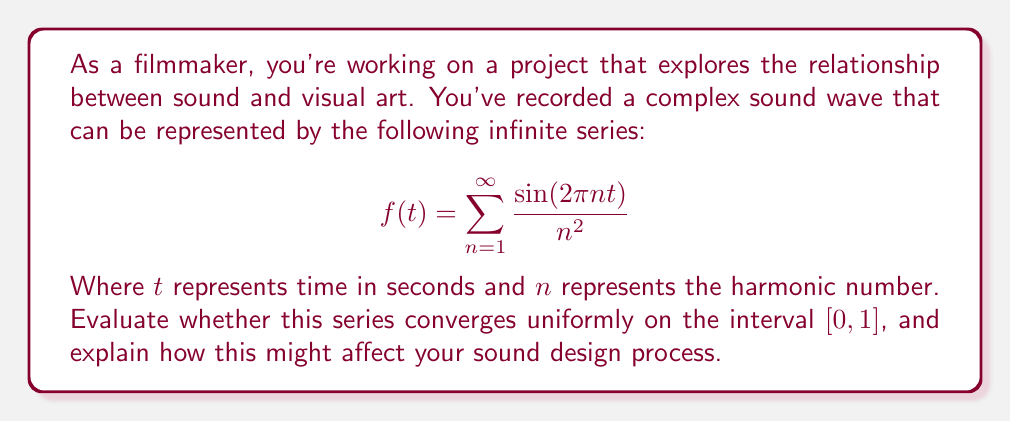Can you solve this math problem? To evaluate the uniform convergence of this series, we'll use the Weierstrass M-test. 

1) First, we need to find a sequence of constants $M_n$ such that:
   $$\left|\frac{\sin(2\pi n t)}{n^2}\right| \leq M_n$$
   for all $t \in [0,1]$ and all $n \geq 1$.

2) We know that $|\sin(x)| \leq 1$ for all $x$. Therefore:
   $$\left|\frac{\sin(2\pi n t)}{n^2}\right| \leq \frac{1}{n^2}$$

3) So we can choose $M_n = \frac{1}{n^2}$.

4) Now we need to check if $\sum_{n=1}^{\infty} M_n$ converges:
   $$\sum_{n=1}^{\infty} M_n = \sum_{n=1}^{\infty} \frac{1}{n^2}$$

5) This is the famous Basel problem series, which is known to converge to $\frac{\pi^2}{6}$.

6) Since $\sum_{n=1}^{\infty} M_n$ converges, by the Weierstrass M-test, the original series converges uniformly on $[0,1]$.

For a filmmaker, this uniform convergence has important implications:

1) The sound wave represented by this series is well-behaved and consistent across the entire time interval $[0,1]$.
2) You can approximate the sound wave accurately by using a finite number of terms, and this approximation will be uniformly good across the entire interval.
3) This allows for precise control over the sound design, as the behavior of the wave is predictable and stable.
4) You can create interesting audio effects by manipulating the coefficients of the series while maintaining its convergence properties.
Answer: The series converges uniformly on the interval $[0,1]$. 